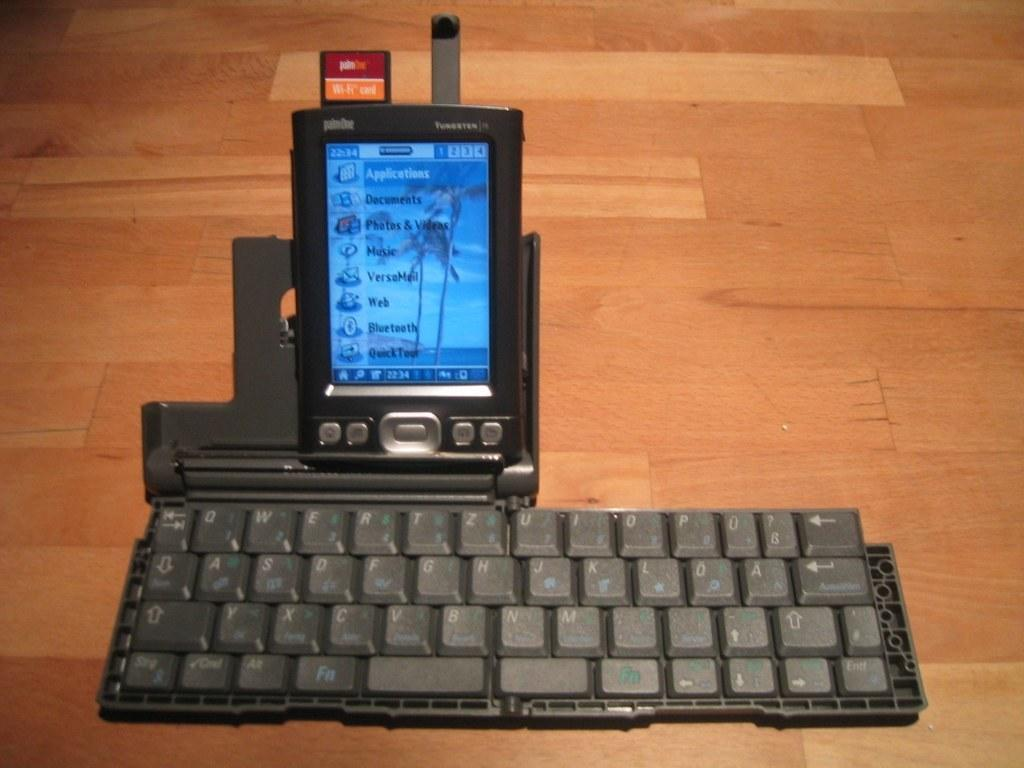<image>
Give a short and clear explanation of the subsequent image. a palmOne phone hooked up to a keyboard on a wooden table 